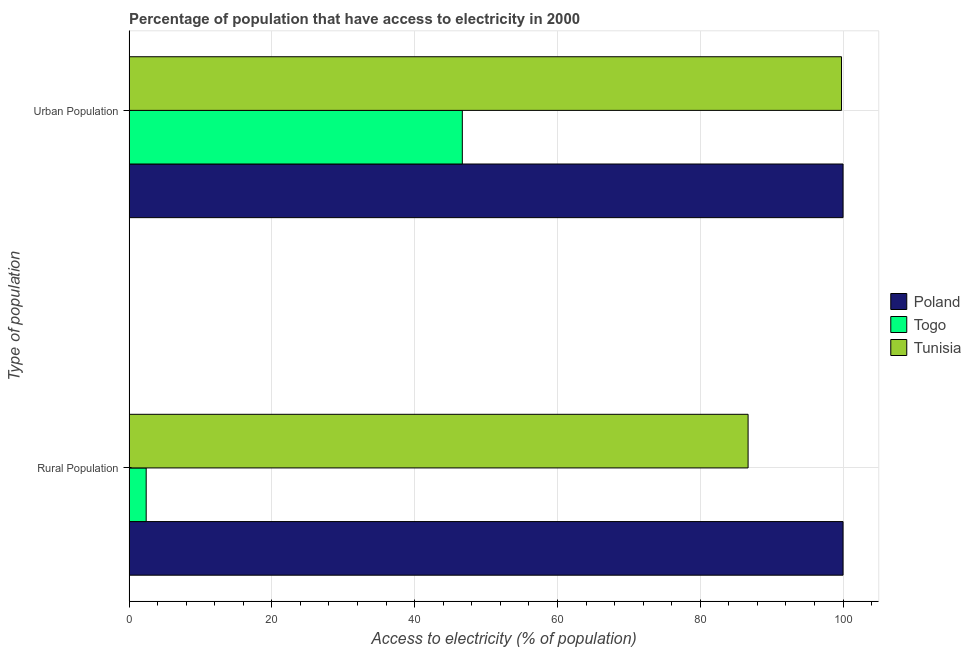Are the number of bars per tick equal to the number of legend labels?
Offer a terse response. Yes. How many bars are there on the 2nd tick from the top?
Keep it short and to the point. 3. How many bars are there on the 1st tick from the bottom?
Your answer should be compact. 3. What is the label of the 2nd group of bars from the top?
Offer a very short reply. Rural Population. What is the percentage of urban population having access to electricity in Poland?
Make the answer very short. 100. Across all countries, what is the minimum percentage of urban population having access to electricity?
Provide a succinct answer. 46.68. In which country was the percentage of urban population having access to electricity maximum?
Provide a succinct answer. Poland. In which country was the percentage of urban population having access to electricity minimum?
Your response must be concise. Togo. What is the total percentage of rural population having access to electricity in the graph?
Provide a succinct answer. 189.1. What is the difference between the percentage of rural population having access to electricity in Togo and that in Tunisia?
Ensure brevity in your answer.  -84.3. What is the difference between the percentage of rural population having access to electricity in Poland and the percentage of urban population having access to electricity in Togo?
Your answer should be very brief. 53.32. What is the average percentage of rural population having access to electricity per country?
Give a very brief answer. 63.03. What is the difference between the percentage of urban population having access to electricity and percentage of rural population having access to electricity in Tunisia?
Provide a succinct answer. 13.08. What is the ratio of the percentage of rural population having access to electricity in Poland to that in Togo?
Your answer should be compact. 41.67. Is the percentage of urban population having access to electricity in Tunisia less than that in Togo?
Your answer should be compact. No. What does the 3rd bar from the top in Urban Population represents?
Your response must be concise. Poland. How many bars are there?
Your answer should be compact. 6. Are all the bars in the graph horizontal?
Offer a very short reply. Yes. What is the difference between two consecutive major ticks on the X-axis?
Your answer should be very brief. 20. Does the graph contain any zero values?
Ensure brevity in your answer.  No. Where does the legend appear in the graph?
Make the answer very short. Center right. What is the title of the graph?
Make the answer very short. Percentage of population that have access to electricity in 2000. What is the label or title of the X-axis?
Keep it short and to the point. Access to electricity (% of population). What is the label or title of the Y-axis?
Provide a short and direct response. Type of population. What is the Access to electricity (% of population) of Tunisia in Rural Population?
Ensure brevity in your answer.  86.7. What is the Access to electricity (% of population) in Togo in Urban Population?
Provide a short and direct response. 46.68. What is the Access to electricity (% of population) in Tunisia in Urban Population?
Offer a terse response. 99.78. Across all Type of population, what is the maximum Access to electricity (% of population) in Togo?
Offer a terse response. 46.68. Across all Type of population, what is the maximum Access to electricity (% of population) of Tunisia?
Your response must be concise. 99.78. Across all Type of population, what is the minimum Access to electricity (% of population) in Togo?
Provide a short and direct response. 2.4. Across all Type of population, what is the minimum Access to electricity (% of population) in Tunisia?
Give a very brief answer. 86.7. What is the total Access to electricity (% of population) of Poland in the graph?
Provide a succinct answer. 200. What is the total Access to electricity (% of population) of Togo in the graph?
Offer a terse response. 49.08. What is the total Access to electricity (% of population) of Tunisia in the graph?
Offer a terse response. 186.48. What is the difference between the Access to electricity (% of population) of Poland in Rural Population and that in Urban Population?
Your answer should be very brief. 0. What is the difference between the Access to electricity (% of population) in Togo in Rural Population and that in Urban Population?
Provide a short and direct response. -44.28. What is the difference between the Access to electricity (% of population) in Tunisia in Rural Population and that in Urban Population?
Provide a succinct answer. -13.08. What is the difference between the Access to electricity (% of population) in Poland in Rural Population and the Access to electricity (% of population) in Togo in Urban Population?
Give a very brief answer. 53.32. What is the difference between the Access to electricity (% of population) of Poland in Rural Population and the Access to electricity (% of population) of Tunisia in Urban Population?
Ensure brevity in your answer.  0.22. What is the difference between the Access to electricity (% of population) of Togo in Rural Population and the Access to electricity (% of population) of Tunisia in Urban Population?
Give a very brief answer. -97.38. What is the average Access to electricity (% of population) in Togo per Type of population?
Ensure brevity in your answer.  24.54. What is the average Access to electricity (% of population) of Tunisia per Type of population?
Offer a very short reply. 93.24. What is the difference between the Access to electricity (% of population) of Poland and Access to electricity (% of population) of Togo in Rural Population?
Make the answer very short. 97.6. What is the difference between the Access to electricity (% of population) in Poland and Access to electricity (% of population) in Tunisia in Rural Population?
Provide a short and direct response. 13.3. What is the difference between the Access to electricity (% of population) of Togo and Access to electricity (% of population) of Tunisia in Rural Population?
Give a very brief answer. -84.3. What is the difference between the Access to electricity (% of population) in Poland and Access to electricity (% of population) in Togo in Urban Population?
Make the answer very short. 53.32. What is the difference between the Access to electricity (% of population) of Poland and Access to electricity (% of population) of Tunisia in Urban Population?
Offer a terse response. 0.22. What is the difference between the Access to electricity (% of population) of Togo and Access to electricity (% of population) of Tunisia in Urban Population?
Offer a very short reply. -53.11. What is the ratio of the Access to electricity (% of population) of Togo in Rural Population to that in Urban Population?
Keep it short and to the point. 0.05. What is the ratio of the Access to electricity (% of population) in Tunisia in Rural Population to that in Urban Population?
Your response must be concise. 0.87. What is the difference between the highest and the second highest Access to electricity (% of population) of Togo?
Offer a very short reply. 44.28. What is the difference between the highest and the second highest Access to electricity (% of population) in Tunisia?
Ensure brevity in your answer.  13.08. What is the difference between the highest and the lowest Access to electricity (% of population) in Togo?
Your response must be concise. 44.28. What is the difference between the highest and the lowest Access to electricity (% of population) in Tunisia?
Keep it short and to the point. 13.08. 